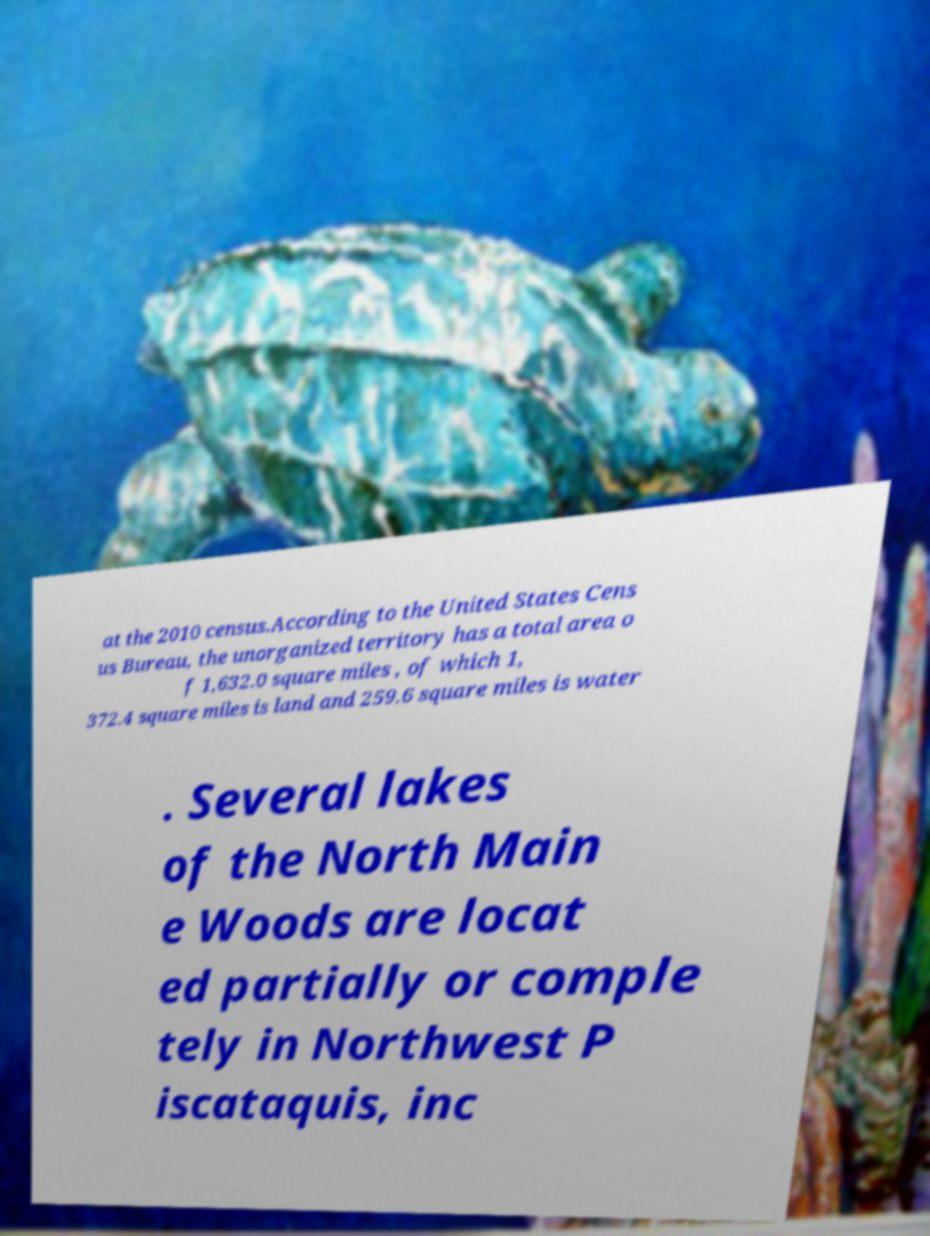Can you accurately transcribe the text from the provided image for me? at the 2010 census.According to the United States Cens us Bureau, the unorganized territory has a total area o f 1,632.0 square miles , of which 1, 372.4 square miles is land and 259.6 square miles is water . Several lakes of the North Main e Woods are locat ed partially or comple tely in Northwest P iscataquis, inc 